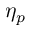Convert formula to latex. <formula><loc_0><loc_0><loc_500><loc_500>\eta _ { p }</formula> 